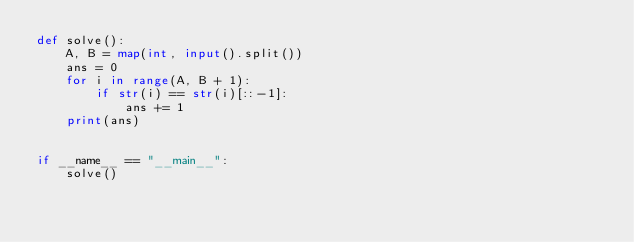Convert code to text. <code><loc_0><loc_0><loc_500><loc_500><_Python_>def solve():
    A, B = map(int, input().split())
    ans = 0
    for i in range(A, B + 1):
        if str(i) == str(i)[::-1]:
            ans += 1
    print(ans)


if __name__ == "__main__":
    solve()
</code> 